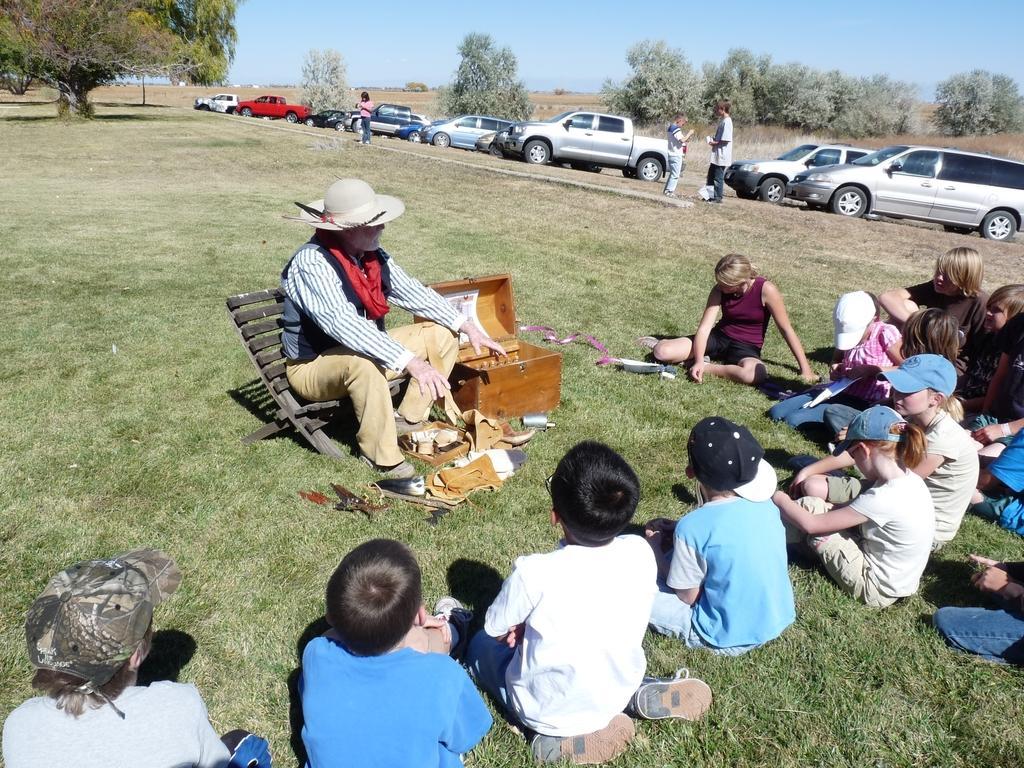Can you describe this image briefly? In this picture we can see some people sitting on the ground, at the bottom there is grass, there is a man sitting on a chair in the middle, we can see a box behind him, on the right side there are some vehicles, we can see trees in the background, there are three persons standing in the middle, we can see the sky at the top of the picture. 